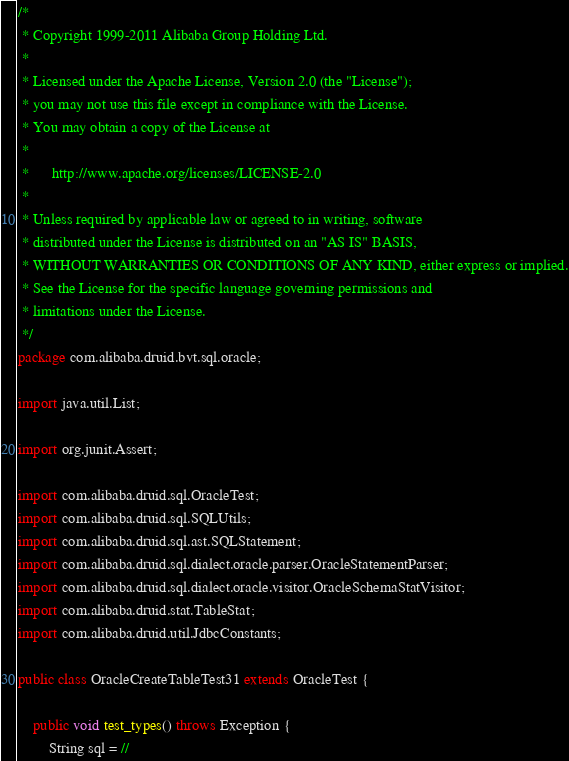Convert code to text. <code><loc_0><loc_0><loc_500><loc_500><_Java_>/*
 * Copyright 1999-2011 Alibaba Group Holding Ltd.
 *
 * Licensed under the Apache License, Version 2.0 (the "License");
 * you may not use this file except in compliance with the License.
 * You may obtain a copy of the License at
 *
 *      http://www.apache.org/licenses/LICENSE-2.0
 *
 * Unless required by applicable law or agreed to in writing, software
 * distributed under the License is distributed on an "AS IS" BASIS,
 * WITHOUT WARRANTIES OR CONDITIONS OF ANY KIND, either express or implied.
 * See the License for the specific language governing permissions and
 * limitations under the License.
 */
package com.alibaba.druid.bvt.sql.oracle;

import java.util.List;

import org.junit.Assert;

import com.alibaba.druid.sql.OracleTest;
import com.alibaba.druid.sql.SQLUtils;
import com.alibaba.druid.sql.ast.SQLStatement;
import com.alibaba.druid.sql.dialect.oracle.parser.OracleStatementParser;
import com.alibaba.druid.sql.dialect.oracle.visitor.OracleSchemaStatVisitor;
import com.alibaba.druid.stat.TableStat;
import com.alibaba.druid.util.JdbcConstants;

public class OracleCreateTableTest31 extends OracleTest {

    public void test_types() throws Exception {
        String sql = //</code> 